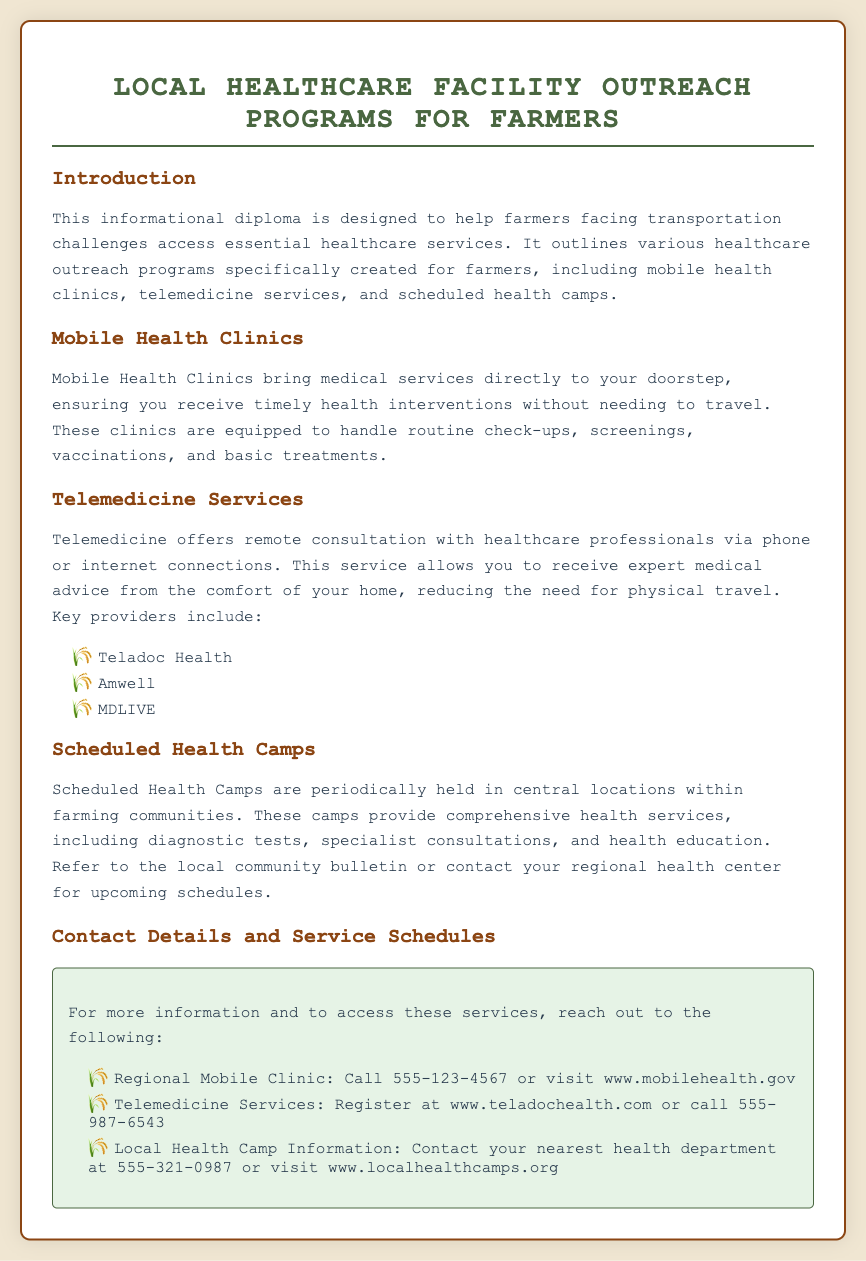What is the title of the document? The title is prominently displayed at the top of the document, indicating the main topic.
Answer: Local Healthcare Facility Outreach Programs for Farmers What types of outreach programs are mentioned? The document lists specific outreach programs tailored for farmers in the healthcare context.
Answer: Mobile health clinics, telemedicine services, scheduled health camps What is the phone number for the Regional Mobile Clinic? The phone number is provided in the contact details section for easy reference by farmers.
Answer: 555-123-4567 Which telemedicine service is listed first? The document presents a list of telemedicine services in a specific order, starting with the first one.
Answer: Teladoc Health What type of services do Mobile Health Clinics provide? The document describes the services offered by Mobile Health Clinics in a summarized format.
Answer: Timely health interventions What should farmers do to find out about Scheduled Health Camps? The document advises farmers on where to find information regarding health camp schedules.
Answer: Refer to the local community bulletin or contact your regional health center How can farmers access Telemedicine Services? The document includes specific instructions for registration or contact for telemedicine services.
Answer: Register at www.teladochealth.com What color is the background of the document? The answer is inferred from the styling defined in the document's code.
Answer: Light beige 